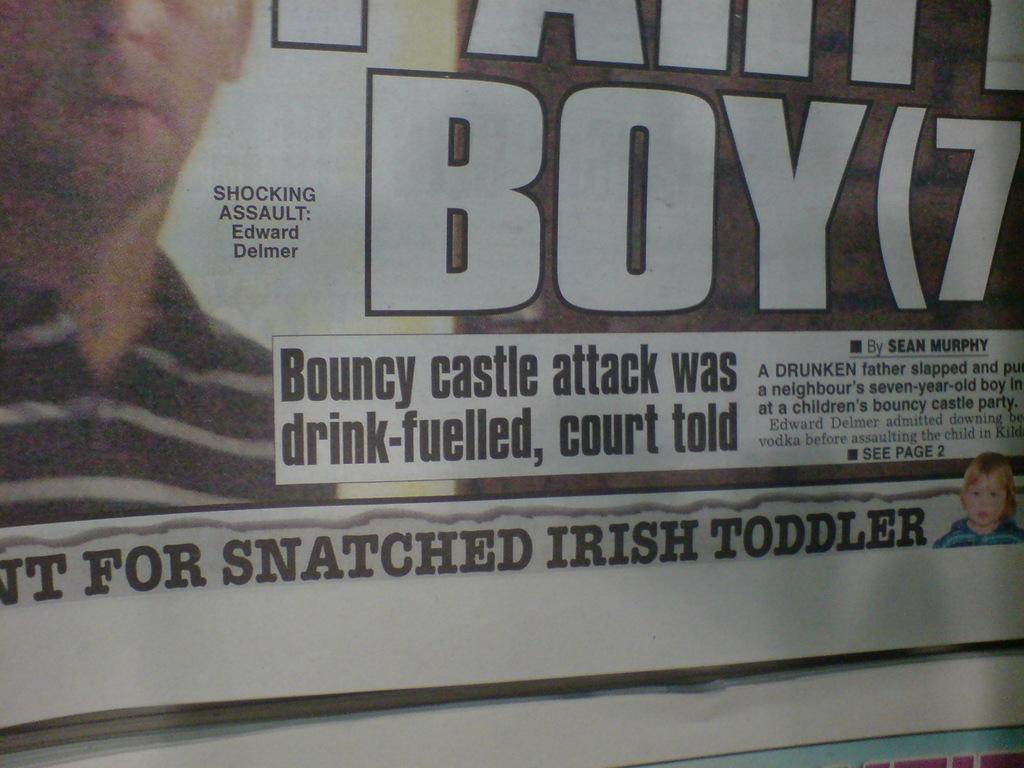How would you summarize this image in a sentence or two? In this image we can see there is a paper and there is some text and images on it. 